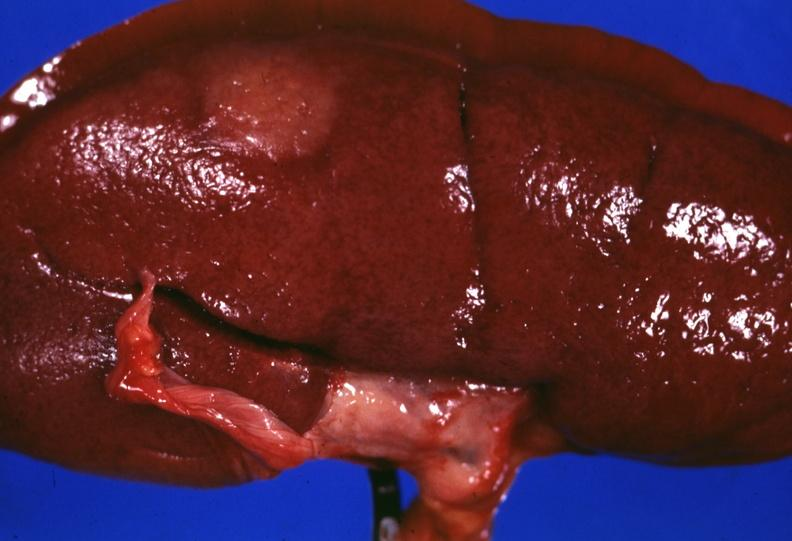does this image show surface lesion capsule stripped unusual?
Answer the question using a single word or phrase. Yes 